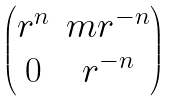Convert formula to latex. <formula><loc_0><loc_0><loc_500><loc_500>\begin{pmatrix} r ^ { n } & m r ^ { - n } \\ 0 & r ^ { - n } \end{pmatrix}</formula> 